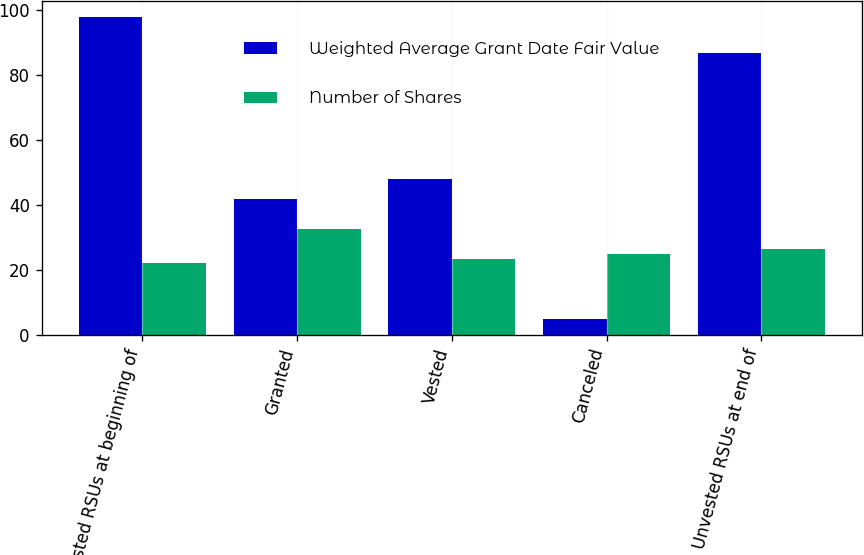<chart> <loc_0><loc_0><loc_500><loc_500><stacked_bar_chart><ecel><fcel>Unvested RSUs at beginning of<fcel>Granted<fcel>Vested<fcel>Canceled<fcel>Unvested RSUs at end of<nl><fcel>Weighted Average Grant Date Fair Value<fcel>98<fcel>42<fcel>48<fcel>5<fcel>87<nl><fcel>Number of Shares<fcel>22.29<fcel>32.58<fcel>23.51<fcel>25.04<fcel>26.44<nl></chart> 